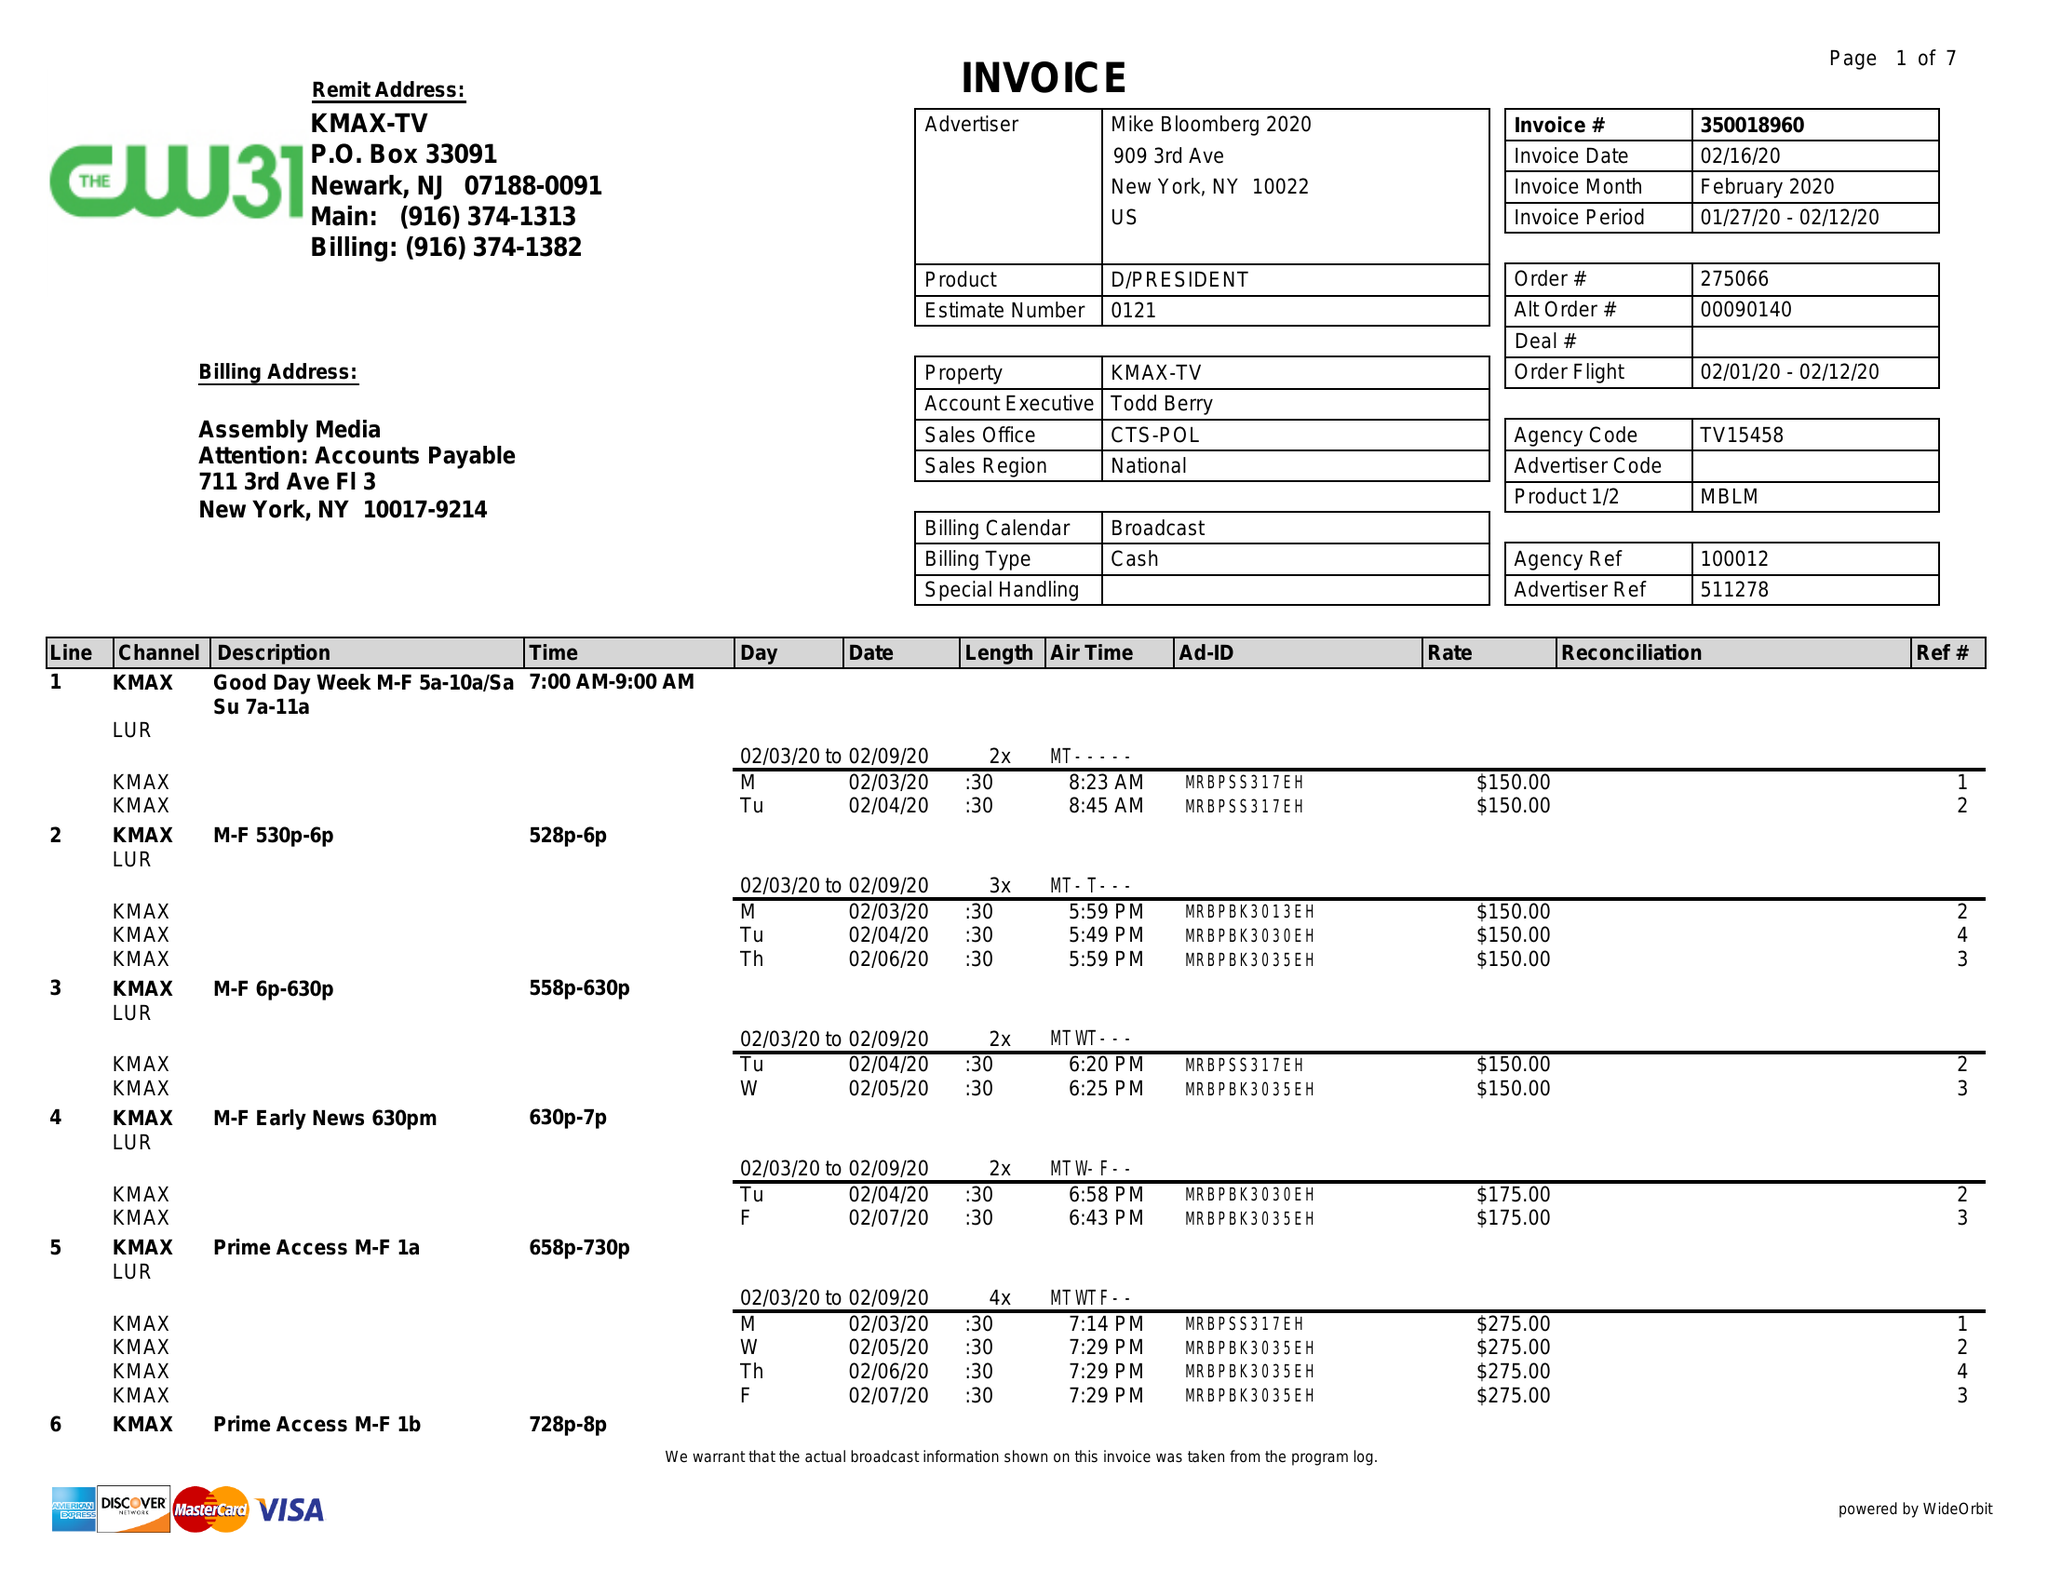What is the value for the gross_amount?
Answer the question using a single word or phrase. 14550.00 